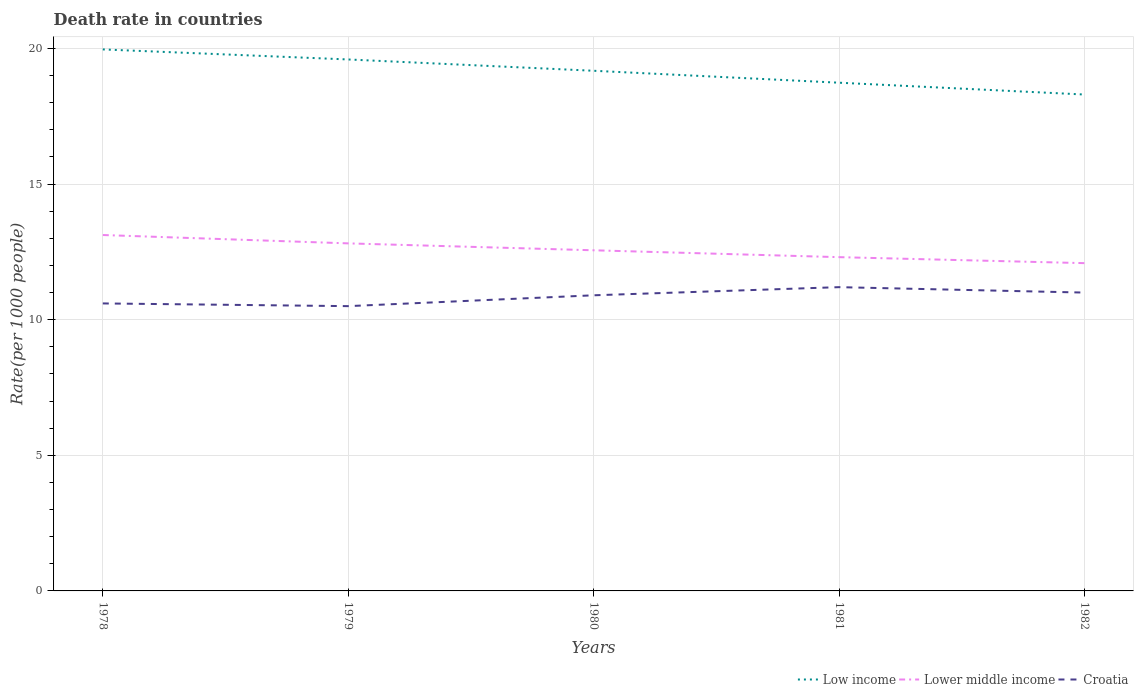How many different coloured lines are there?
Keep it short and to the point. 3. Is the number of lines equal to the number of legend labels?
Provide a short and direct response. Yes. Across all years, what is the maximum death rate in Lower middle income?
Keep it short and to the point. 12.09. In which year was the death rate in Low income maximum?
Provide a succinct answer. 1982. What is the total death rate in Lower middle income in the graph?
Provide a short and direct response. 0.82. What is the difference between the highest and the second highest death rate in Low income?
Your answer should be very brief. 1.66. What is the difference between the highest and the lowest death rate in Lower middle income?
Give a very brief answer. 2. Is the death rate in Croatia strictly greater than the death rate in Low income over the years?
Your response must be concise. Yes. How many years are there in the graph?
Provide a short and direct response. 5. Does the graph contain grids?
Provide a succinct answer. Yes. Where does the legend appear in the graph?
Provide a short and direct response. Bottom right. How are the legend labels stacked?
Your answer should be very brief. Horizontal. What is the title of the graph?
Make the answer very short. Death rate in countries. Does "Mauritania" appear as one of the legend labels in the graph?
Your answer should be compact. No. What is the label or title of the Y-axis?
Give a very brief answer. Rate(per 1000 people). What is the Rate(per 1000 people) in Low income in 1978?
Ensure brevity in your answer.  19.97. What is the Rate(per 1000 people) of Lower middle income in 1978?
Provide a succinct answer. 13.12. What is the Rate(per 1000 people) of Low income in 1979?
Offer a very short reply. 19.6. What is the Rate(per 1000 people) of Lower middle income in 1979?
Ensure brevity in your answer.  12.81. What is the Rate(per 1000 people) in Croatia in 1979?
Offer a terse response. 10.5. What is the Rate(per 1000 people) in Low income in 1980?
Offer a terse response. 19.18. What is the Rate(per 1000 people) of Lower middle income in 1980?
Provide a succinct answer. 12.56. What is the Rate(per 1000 people) of Low income in 1981?
Your answer should be very brief. 18.74. What is the Rate(per 1000 people) in Lower middle income in 1981?
Provide a short and direct response. 12.31. What is the Rate(per 1000 people) in Low income in 1982?
Offer a terse response. 18.3. What is the Rate(per 1000 people) of Lower middle income in 1982?
Keep it short and to the point. 12.09. What is the Rate(per 1000 people) in Croatia in 1982?
Ensure brevity in your answer.  11. Across all years, what is the maximum Rate(per 1000 people) in Low income?
Your response must be concise. 19.97. Across all years, what is the maximum Rate(per 1000 people) in Lower middle income?
Ensure brevity in your answer.  13.12. Across all years, what is the maximum Rate(per 1000 people) of Croatia?
Provide a short and direct response. 11.2. Across all years, what is the minimum Rate(per 1000 people) in Low income?
Offer a very short reply. 18.3. Across all years, what is the minimum Rate(per 1000 people) in Lower middle income?
Your answer should be very brief. 12.09. Across all years, what is the minimum Rate(per 1000 people) of Croatia?
Make the answer very short. 10.5. What is the total Rate(per 1000 people) in Low income in the graph?
Ensure brevity in your answer.  95.78. What is the total Rate(per 1000 people) in Lower middle income in the graph?
Offer a terse response. 62.89. What is the total Rate(per 1000 people) in Croatia in the graph?
Offer a terse response. 54.2. What is the difference between the Rate(per 1000 people) in Low income in 1978 and that in 1979?
Provide a short and direct response. 0.37. What is the difference between the Rate(per 1000 people) in Lower middle income in 1978 and that in 1979?
Your response must be concise. 0.31. What is the difference between the Rate(per 1000 people) of Croatia in 1978 and that in 1979?
Offer a terse response. 0.1. What is the difference between the Rate(per 1000 people) in Low income in 1978 and that in 1980?
Your response must be concise. 0.79. What is the difference between the Rate(per 1000 people) in Lower middle income in 1978 and that in 1980?
Ensure brevity in your answer.  0.56. What is the difference between the Rate(per 1000 people) in Croatia in 1978 and that in 1980?
Your answer should be compact. -0.3. What is the difference between the Rate(per 1000 people) in Low income in 1978 and that in 1981?
Your response must be concise. 1.23. What is the difference between the Rate(per 1000 people) of Lower middle income in 1978 and that in 1981?
Your answer should be compact. 0.82. What is the difference between the Rate(per 1000 people) in Low income in 1978 and that in 1982?
Provide a succinct answer. 1.66. What is the difference between the Rate(per 1000 people) in Lower middle income in 1978 and that in 1982?
Your response must be concise. 1.04. What is the difference between the Rate(per 1000 people) in Croatia in 1978 and that in 1982?
Keep it short and to the point. -0.4. What is the difference between the Rate(per 1000 people) of Low income in 1979 and that in 1980?
Provide a succinct answer. 0.42. What is the difference between the Rate(per 1000 people) of Lower middle income in 1979 and that in 1980?
Provide a succinct answer. 0.25. What is the difference between the Rate(per 1000 people) of Low income in 1979 and that in 1981?
Offer a very short reply. 0.86. What is the difference between the Rate(per 1000 people) in Lower middle income in 1979 and that in 1981?
Your response must be concise. 0.51. What is the difference between the Rate(per 1000 people) of Croatia in 1979 and that in 1981?
Ensure brevity in your answer.  -0.7. What is the difference between the Rate(per 1000 people) of Low income in 1979 and that in 1982?
Provide a short and direct response. 1.29. What is the difference between the Rate(per 1000 people) of Lower middle income in 1979 and that in 1982?
Make the answer very short. 0.73. What is the difference between the Rate(per 1000 people) in Low income in 1980 and that in 1981?
Ensure brevity in your answer.  0.44. What is the difference between the Rate(per 1000 people) in Lower middle income in 1980 and that in 1981?
Offer a very short reply. 0.25. What is the difference between the Rate(per 1000 people) in Low income in 1980 and that in 1982?
Provide a succinct answer. 0.88. What is the difference between the Rate(per 1000 people) in Lower middle income in 1980 and that in 1982?
Give a very brief answer. 0.47. What is the difference between the Rate(per 1000 people) of Croatia in 1980 and that in 1982?
Offer a very short reply. -0.1. What is the difference between the Rate(per 1000 people) of Low income in 1981 and that in 1982?
Offer a very short reply. 0.44. What is the difference between the Rate(per 1000 people) in Lower middle income in 1981 and that in 1982?
Your answer should be very brief. 0.22. What is the difference between the Rate(per 1000 people) in Croatia in 1981 and that in 1982?
Provide a short and direct response. 0.2. What is the difference between the Rate(per 1000 people) of Low income in 1978 and the Rate(per 1000 people) of Lower middle income in 1979?
Offer a terse response. 7.15. What is the difference between the Rate(per 1000 people) in Low income in 1978 and the Rate(per 1000 people) in Croatia in 1979?
Your answer should be very brief. 9.47. What is the difference between the Rate(per 1000 people) of Lower middle income in 1978 and the Rate(per 1000 people) of Croatia in 1979?
Your answer should be compact. 2.62. What is the difference between the Rate(per 1000 people) in Low income in 1978 and the Rate(per 1000 people) in Lower middle income in 1980?
Your answer should be compact. 7.41. What is the difference between the Rate(per 1000 people) of Low income in 1978 and the Rate(per 1000 people) of Croatia in 1980?
Keep it short and to the point. 9.07. What is the difference between the Rate(per 1000 people) in Lower middle income in 1978 and the Rate(per 1000 people) in Croatia in 1980?
Offer a terse response. 2.22. What is the difference between the Rate(per 1000 people) in Low income in 1978 and the Rate(per 1000 people) in Lower middle income in 1981?
Provide a succinct answer. 7.66. What is the difference between the Rate(per 1000 people) of Low income in 1978 and the Rate(per 1000 people) of Croatia in 1981?
Offer a very short reply. 8.77. What is the difference between the Rate(per 1000 people) of Lower middle income in 1978 and the Rate(per 1000 people) of Croatia in 1981?
Provide a short and direct response. 1.92. What is the difference between the Rate(per 1000 people) of Low income in 1978 and the Rate(per 1000 people) of Lower middle income in 1982?
Offer a very short reply. 7.88. What is the difference between the Rate(per 1000 people) in Low income in 1978 and the Rate(per 1000 people) in Croatia in 1982?
Provide a short and direct response. 8.97. What is the difference between the Rate(per 1000 people) of Lower middle income in 1978 and the Rate(per 1000 people) of Croatia in 1982?
Provide a succinct answer. 2.12. What is the difference between the Rate(per 1000 people) in Low income in 1979 and the Rate(per 1000 people) in Lower middle income in 1980?
Ensure brevity in your answer.  7.04. What is the difference between the Rate(per 1000 people) of Low income in 1979 and the Rate(per 1000 people) of Croatia in 1980?
Keep it short and to the point. 8.7. What is the difference between the Rate(per 1000 people) of Lower middle income in 1979 and the Rate(per 1000 people) of Croatia in 1980?
Provide a succinct answer. 1.91. What is the difference between the Rate(per 1000 people) of Low income in 1979 and the Rate(per 1000 people) of Lower middle income in 1981?
Provide a succinct answer. 7.29. What is the difference between the Rate(per 1000 people) in Low income in 1979 and the Rate(per 1000 people) in Croatia in 1981?
Your response must be concise. 8.4. What is the difference between the Rate(per 1000 people) in Lower middle income in 1979 and the Rate(per 1000 people) in Croatia in 1981?
Keep it short and to the point. 1.61. What is the difference between the Rate(per 1000 people) of Low income in 1979 and the Rate(per 1000 people) of Lower middle income in 1982?
Provide a short and direct response. 7.51. What is the difference between the Rate(per 1000 people) in Low income in 1979 and the Rate(per 1000 people) in Croatia in 1982?
Your answer should be compact. 8.6. What is the difference between the Rate(per 1000 people) in Lower middle income in 1979 and the Rate(per 1000 people) in Croatia in 1982?
Make the answer very short. 1.81. What is the difference between the Rate(per 1000 people) in Low income in 1980 and the Rate(per 1000 people) in Lower middle income in 1981?
Your answer should be compact. 6.87. What is the difference between the Rate(per 1000 people) of Low income in 1980 and the Rate(per 1000 people) of Croatia in 1981?
Make the answer very short. 7.98. What is the difference between the Rate(per 1000 people) in Lower middle income in 1980 and the Rate(per 1000 people) in Croatia in 1981?
Keep it short and to the point. 1.36. What is the difference between the Rate(per 1000 people) of Low income in 1980 and the Rate(per 1000 people) of Lower middle income in 1982?
Your answer should be very brief. 7.09. What is the difference between the Rate(per 1000 people) in Low income in 1980 and the Rate(per 1000 people) in Croatia in 1982?
Provide a succinct answer. 8.18. What is the difference between the Rate(per 1000 people) in Lower middle income in 1980 and the Rate(per 1000 people) in Croatia in 1982?
Your answer should be compact. 1.56. What is the difference between the Rate(per 1000 people) of Low income in 1981 and the Rate(per 1000 people) of Lower middle income in 1982?
Provide a succinct answer. 6.65. What is the difference between the Rate(per 1000 people) in Low income in 1981 and the Rate(per 1000 people) in Croatia in 1982?
Your response must be concise. 7.74. What is the difference between the Rate(per 1000 people) in Lower middle income in 1981 and the Rate(per 1000 people) in Croatia in 1982?
Give a very brief answer. 1.31. What is the average Rate(per 1000 people) in Low income per year?
Ensure brevity in your answer.  19.16. What is the average Rate(per 1000 people) of Lower middle income per year?
Make the answer very short. 12.58. What is the average Rate(per 1000 people) in Croatia per year?
Your answer should be very brief. 10.84. In the year 1978, what is the difference between the Rate(per 1000 people) in Low income and Rate(per 1000 people) in Lower middle income?
Make the answer very short. 6.84. In the year 1978, what is the difference between the Rate(per 1000 people) of Low income and Rate(per 1000 people) of Croatia?
Ensure brevity in your answer.  9.37. In the year 1978, what is the difference between the Rate(per 1000 people) of Lower middle income and Rate(per 1000 people) of Croatia?
Your answer should be compact. 2.52. In the year 1979, what is the difference between the Rate(per 1000 people) in Low income and Rate(per 1000 people) in Lower middle income?
Provide a succinct answer. 6.78. In the year 1979, what is the difference between the Rate(per 1000 people) in Low income and Rate(per 1000 people) in Croatia?
Offer a terse response. 9.1. In the year 1979, what is the difference between the Rate(per 1000 people) in Lower middle income and Rate(per 1000 people) in Croatia?
Provide a succinct answer. 2.31. In the year 1980, what is the difference between the Rate(per 1000 people) of Low income and Rate(per 1000 people) of Lower middle income?
Give a very brief answer. 6.62. In the year 1980, what is the difference between the Rate(per 1000 people) of Low income and Rate(per 1000 people) of Croatia?
Offer a very short reply. 8.28. In the year 1980, what is the difference between the Rate(per 1000 people) of Lower middle income and Rate(per 1000 people) of Croatia?
Give a very brief answer. 1.66. In the year 1981, what is the difference between the Rate(per 1000 people) in Low income and Rate(per 1000 people) in Lower middle income?
Keep it short and to the point. 6.43. In the year 1981, what is the difference between the Rate(per 1000 people) of Low income and Rate(per 1000 people) of Croatia?
Offer a terse response. 7.54. In the year 1981, what is the difference between the Rate(per 1000 people) in Lower middle income and Rate(per 1000 people) in Croatia?
Give a very brief answer. 1.11. In the year 1982, what is the difference between the Rate(per 1000 people) of Low income and Rate(per 1000 people) of Lower middle income?
Your response must be concise. 6.22. In the year 1982, what is the difference between the Rate(per 1000 people) of Low income and Rate(per 1000 people) of Croatia?
Offer a terse response. 7.3. In the year 1982, what is the difference between the Rate(per 1000 people) of Lower middle income and Rate(per 1000 people) of Croatia?
Your answer should be very brief. 1.09. What is the ratio of the Rate(per 1000 people) of Low income in 1978 to that in 1979?
Offer a terse response. 1.02. What is the ratio of the Rate(per 1000 people) in Croatia in 1978 to that in 1979?
Offer a very short reply. 1.01. What is the ratio of the Rate(per 1000 people) of Low income in 1978 to that in 1980?
Keep it short and to the point. 1.04. What is the ratio of the Rate(per 1000 people) of Lower middle income in 1978 to that in 1980?
Offer a very short reply. 1.04. What is the ratio of the Rate(per 1000 people) in Croatia in 1978 to that in 1980?
Provide a short and direct response. 0.97. What is the ratio of the Rate(per 1000 people) in Low income in 1978 to that in 1981?
Your answer should be compact. 1.07. What is the ratio of the Rate(per 1000 people) of Lower middle income in 1978 to that in 1981?
Your response must be concise. 1.07. What is the ratio of the Rate(per 1000 people) in Croatia in 1978 to that in 1981?
Provide a succinct answer. 0.95. What is the ratio of the Rate(per 1000 people) of Lower middle income in 1978 to that in 1982?
Your response must be concise. 1.09. What is the ratio of the Rate(per 1000 people) in Croatia in 1978 to that in 1982?
Give a very brief answer. 0.96. What is the ratio of the Rate(per 1000 people) in Low income in 1979 to that in 1980?
Your answer should be compact. 1.02. What is the ratio of the Rate(per 1000 people) of Lower middle income in 1979 to that in 1980?
Offer a terse response. 1.02. What is the ratio of the Rate(per 1000 people) in Croatia in 1979 to that in 1980?
Your response must be concise. 0.96. What is the ratio of the Rate(per 1000 people) of Low income in 1979 to that in 1981?
Ensure brevity in your answer.  1.05. What is the ratio of the Rate(per 1000 people) of Lower middle income in 1979 to that in 1981?
Offer a terse response. 1.04. What is the ratio of the Rate(per 1000 people) in Croatia in 1979 to that in 1981?
Keep it short and to the point. 0.94. What is the ratio of the Rate(per 1000 people) of Low income in 1979 to that in 1982?
Give a very brief answer. 1.07. What is the ratio of the Rate(per 1000 people) of Lower middle income in 1979 to that in 1982?
Offer a terse response. 1.06. What is the ratio of the Rate(per 1000 people) in Croatia in 1979 to that in 1982?
Your response must be concise. 0.95. What is the ratio of the Rate(per 1000 people) of Low income in 1980 to that in 1981?
Keep it short and to the point. 1.02. What is the ratio of the Rate(per 1000 people) of Lower middle income in 1980 to that in 1981?
Your response must be concise. 1.02. What is the ratio of the Rate(per 1000 people) in Croatia in 1980 to that in 1981?
Make the answer very short. 0.97. What is the ratio of the Rate(per 1000 people) in Low income in 1980 to that in 1982?
Offer a very short reply. 1.05. What is the ratio of the Rate(per 1000 people) of Lower middle income in 1980 to that in 1982?
Your answer should be compact. 1.04. What is the ratio of the Rate(per 1000 people) of Croatia in 1980 to that in 1982?
Provide a short and direct response. 0.99. What is the ratio of the Rate(per 1000 people) of Low income in 1981 to that in 1982?
Provide a short and direct response. 1.02. What is the ratio of the Rate(per 1000 people) in Lower middle income in 1981 to that in 1982?
Ensure brevity in your answer.  1.02. What is the ratio of the Rate(per 1000 people) of Croatia in 1981 to that in 1982?
Ensure brevity in your answer.  1.02. What is the difference between the highest and the second highest Rate(per 1000 people) of Low income?
Offer a very short reply. 0.37. What is the difference between the highest and the second highest Rate(per 1000 people) of Lower middle income?
Your answer should be compact. 0.31. What is the difference between the highest and the second highest Rate(per 1000 people) in Croatia?
Give a very brief answer. 0.2. What is the difference between the highest and the lowest Rate(per 1000 people) of Low income?
Provide a short and direct response. 1.66. What is the difference between the highest and the lowest Rate(per 1000 people) in Lower middle income?
Your answer should be very brief. 1.04. 